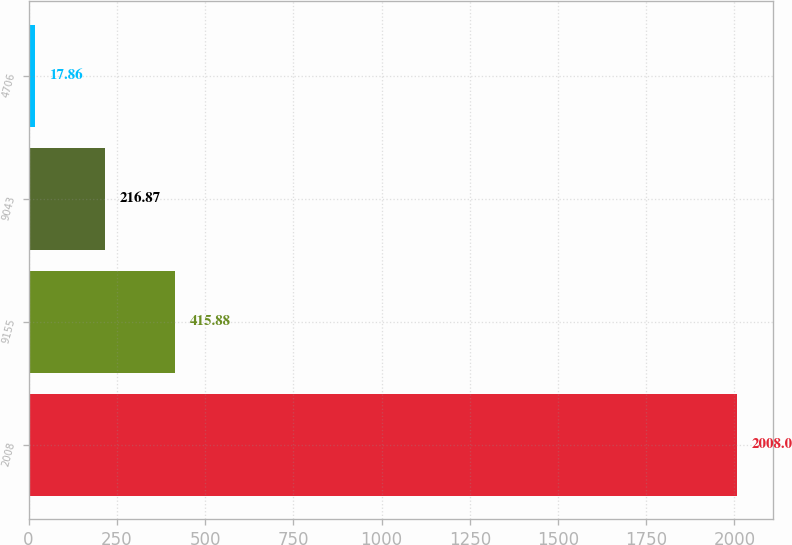<chart> <loc_0><loc_0><loc_500><loc_500><bar_chart><fcel>2008<fcel>9155<fcel>9043<fcel>4706<nl><fcel>2008<fcel>415.88<fcel>216.87<fcel>17.86<nl></chart> 